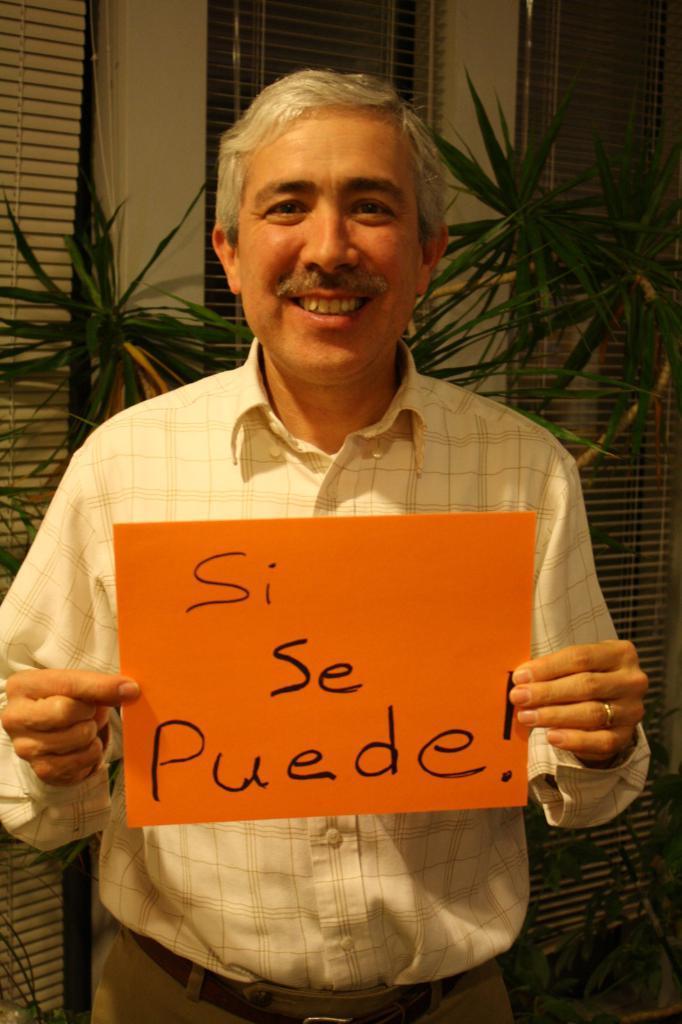Can you describe this image briefly? In this picture I can see a man in the middle, he is holding a placard. In the background there are plants and windows. 